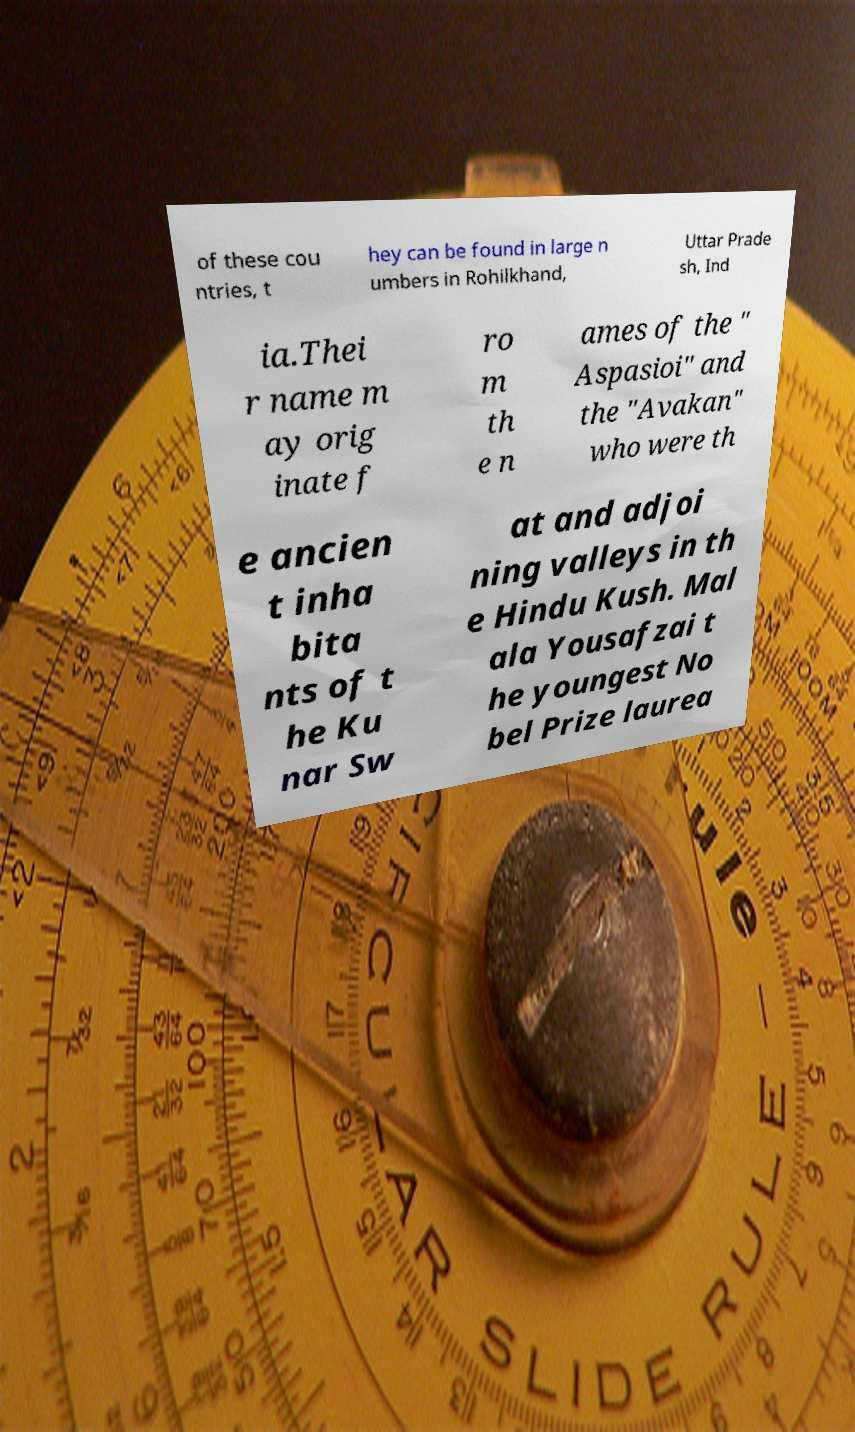Could you assist in decoding the text presented in this image and type it out clearly? of these cou ntries, t hey can be found in large n umbers in Rohilkhand, Uttar Prade sh, Ind ia.Thei r name m ay orig inate f ro m th e n ames of the " Aspasioi" and the "Avakan" who were th e ancien t inha bita nts of t he Ku nar Sw at and adjoi ning valleys in th e Hindu Kush. Mal ala Yousafzai t he youngest No bel Prize laurea 